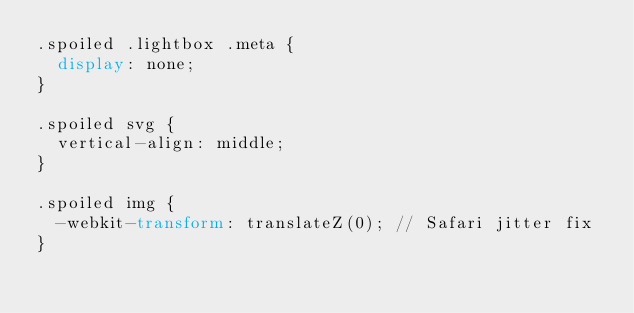Convert code to text. <code><loc_0><loc_0><loc_500><loc_500><_CSS_>.spoiled .lightbox .meta {
  display: none;
}

.spoiled svg {
  vertical-align: middle;
}

.spoiled img {
  -webkit-transform: translateZ(0); // Safari jitter fix
}
</code> 